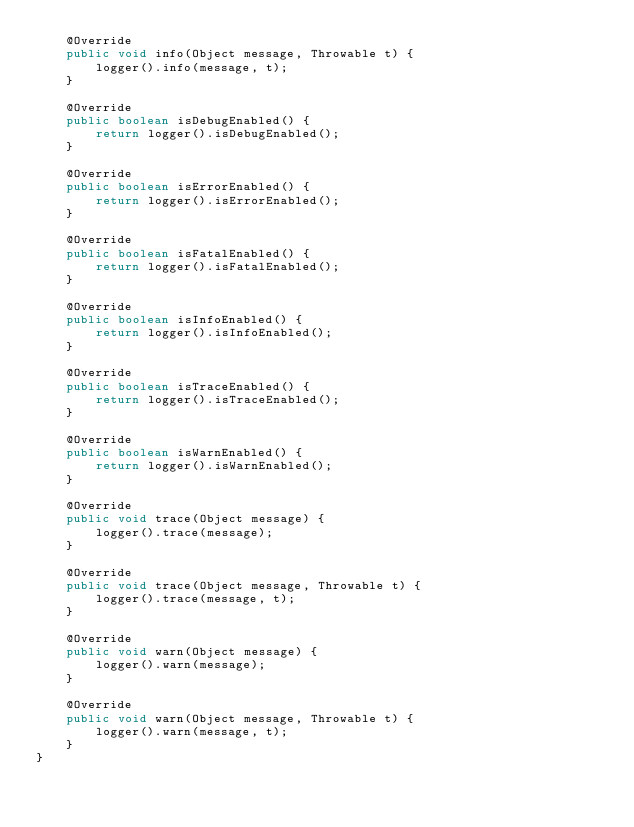<code> <loc_0><loc_0><loc_500><loc_500><_Java_>    @Override
    public void info(Object message, Throwable t) {
        logger().info(message, t);
    }

    @Override
    public boolean isDebugEnabled() {
        return logger().isDebugEnabled();
    }

    @Override
    public boolean isErrorEnabled() {
        return logger().isErrorEnabled();
    }

    @Override
    public boolean isFatalEnabled() {
        return logger().isFatalEnabled();
    }

    @Override
    public boolean isInfoEnabled() {
        return logger().isInfoEnabled();
    }

    @Override
    public boolean isTraceEnabled() {
        return logger().isTraceEnabled();
    }

    @Override
    public boolean isWarnEnabled() {
        return logger().isWarnEnabled();
    }

    @Override
    public void trace(Object message) {
        logger().trace(message);
    }

    @Override
    public void trace(Object message, Throwable t) {
        logger().trace(message, t);
    }

    @Override
    public void warn(Object message) {
        logger().warn(message);
    }

    @Override
    public void warn(Object message, Throwable t) {
        logger().warn(message, t);
    }
}
</code> 